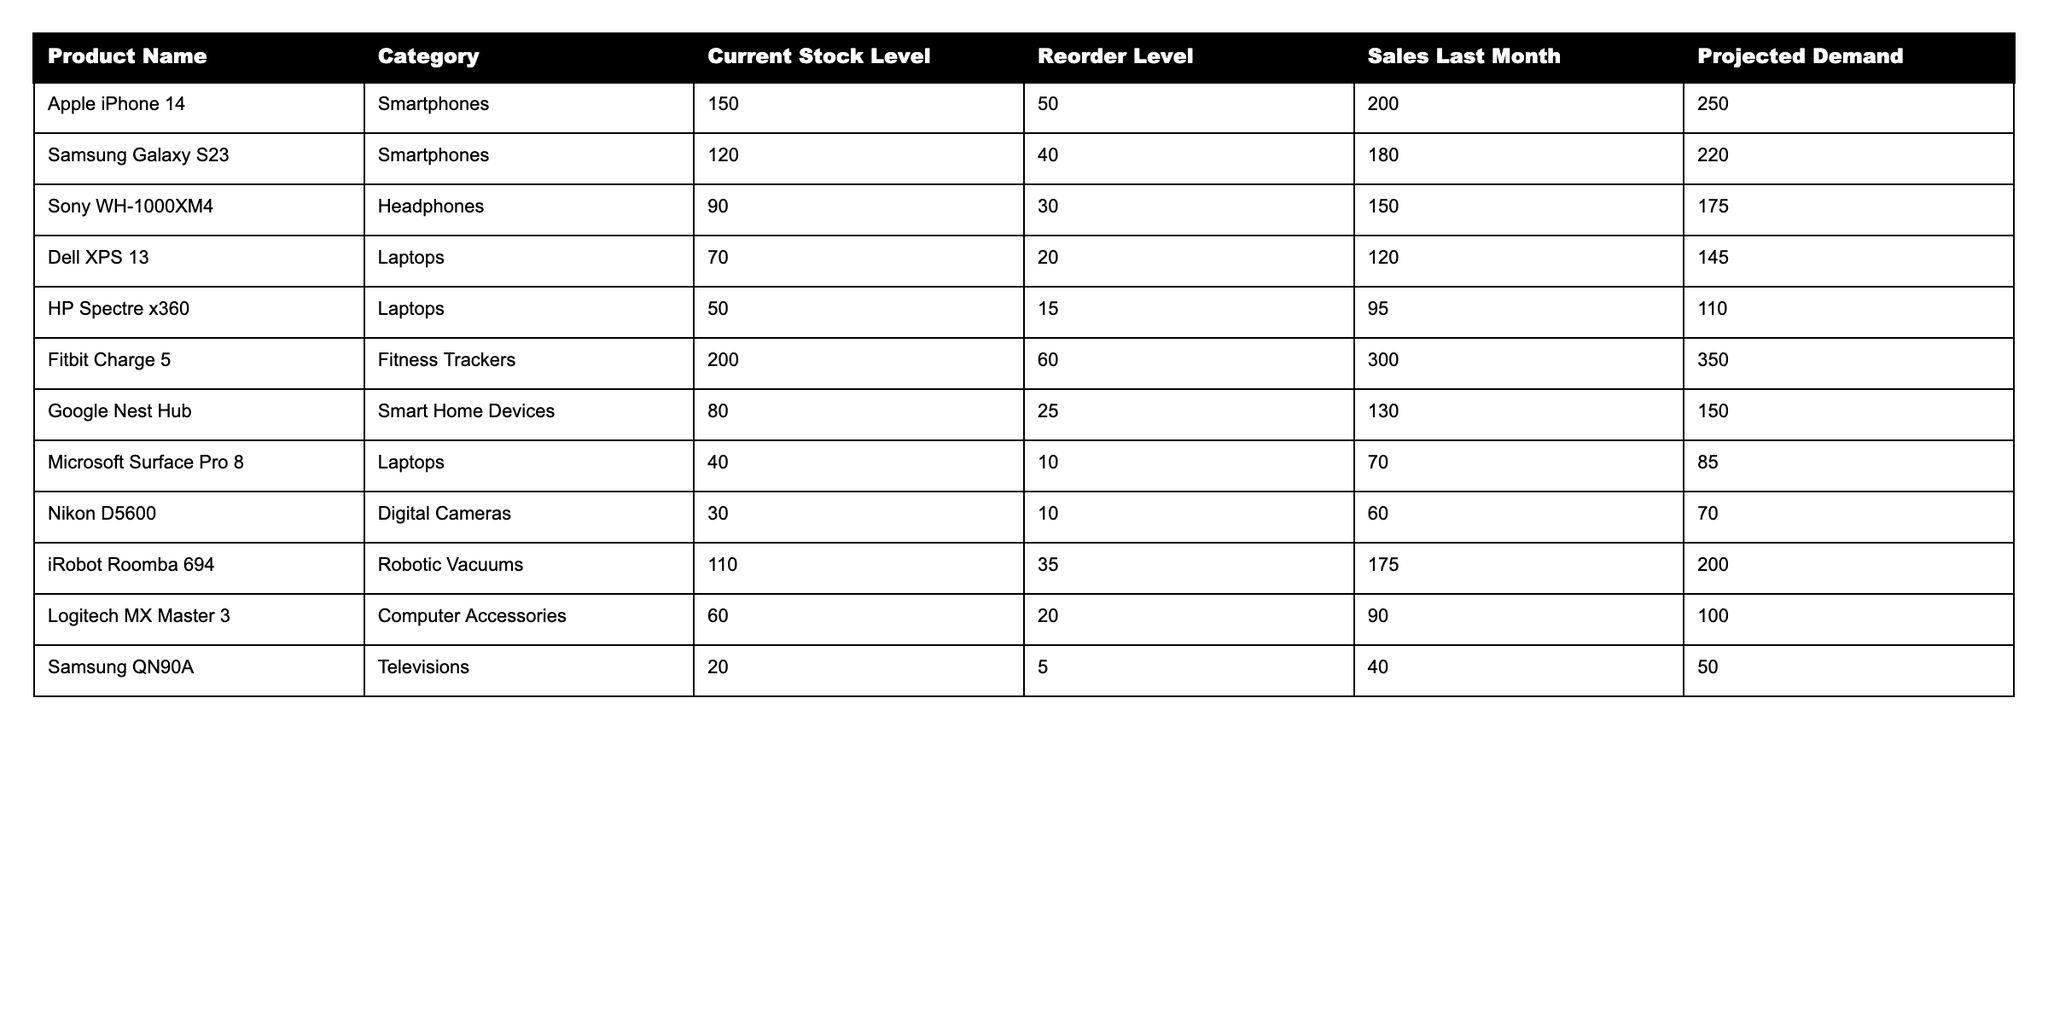What is the current stock level of the Samsung Galaxy S23? The current stock level of the Samsung Galaxy S23 can be found directly in the table under the "Current Stock Level" column. It indicates a stock level of 120.
Answer: 120 How many more Apple iPhone 14 units need to be reordered? The reorder level for the Apple iPhone 14 is 50. Since the current stock level is 150, no additional units need to be reordered. The calculation is 150 - 50 = 100, which means stock is above the reorder level.
Answer: 0 What is the sales figure for the least selling item last month? To find the least selling item, we look at the "Sales Last Month" column and identify the minimum value, which is 60 for the Nikon D5600.
Answer: 60 Which product has the highest projected demand? By examining the "Projected Demand" column, the highest demand is 350 for the Fitbit Charge 5.
Answer: Fitbit Charge 5 Is the current stock level of Google Nest Hub above its reorder level? The current stock level of Google Nest Hub is 80 and the reorder level is 25. Since 80 is greater than 25, the condition is true.
Answer: Yes What is the average current stock level of all laptops? There are three laptops listed: Dell XPS 13 (70), HP Spectre x360 (50), and Microsoft Surface Pro 8 (40). Their total stock level is 70 + 50 + 40 = 160. Dividing by the number of laptops (3) gives an average of 160 / 3 = 53.33.
Answer: 53.33 How many items require immediate reorder based on their current stock levels? An item is considered for immediate reorder if its current stock level is at or below its reorder level. The items to check are: HP Spectre x360 (50 ≤ 15) and Microsoft Surface Pro 8 (40 ≤ 10) which both need a reorder. So, there are 2 items requiring immediate reorder.
Answer: 2 What is the total projected demand for all the smart home devices listed? The only smart home device listed is the Google Nest Hub with a projected demand of 150. As it stands alone, the total projected demand equals its value, which is 150.
Answer: 150 If the total sales last month for headphones and fitness trackers are combined, what is the result? The sales for headphones (Sony WH-1000XM4) is 150 and for fitness trackers (Fitbit Charge 5) is 300. Adding these two values together: 150 + 300 = 450.
Answer: 450 What is the difference between current stock levels for the product with the highest stock and the product with the lowest stock? The product with the highest stock is the Fitbit Charge 5 at 200, and the lowest is the Nikon D5600 at 30. The difference in stock levels is 200 - 30 = 170.
Answer: 170 